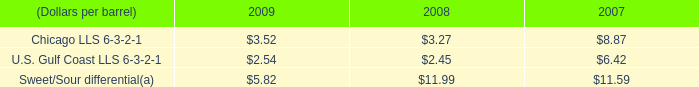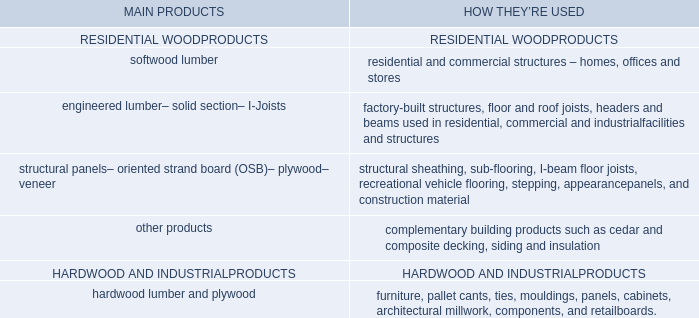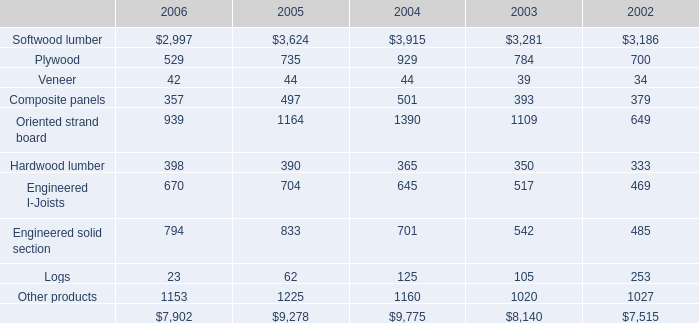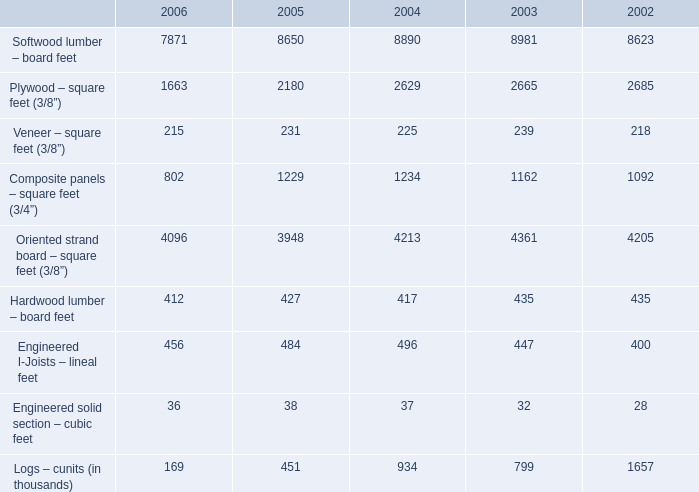In which year is Softwood lumber – board feet greater than 8700? 
Answer: 2004 2003. 